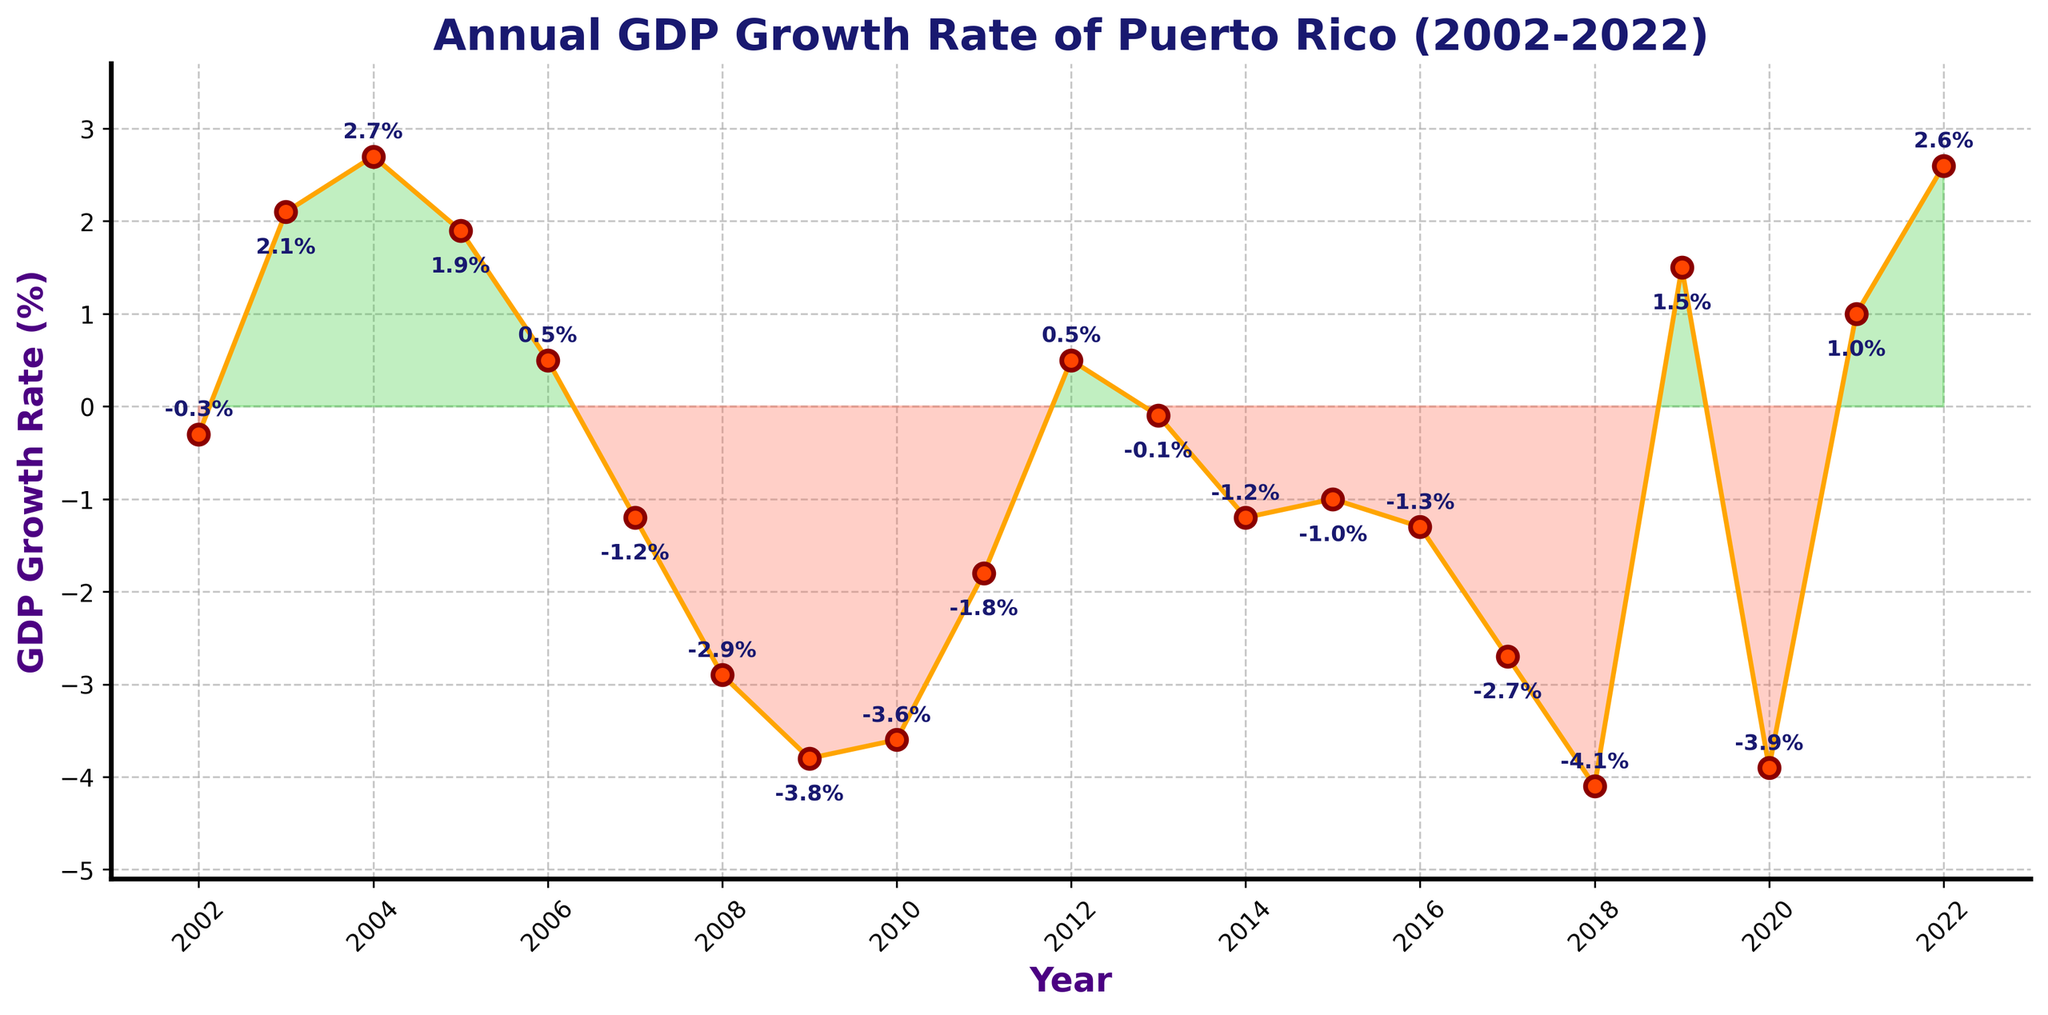Which year had the highest GDP growth rate? To find the year with the highest GDP growth rate, look for the peak point on the line plot. The highest point on the plot occurs in 2004.
Answer: 2004 How many years had a negative GDP growth rate? Count the number of points on the plot that are below the horizontal axis (0% growth rate). Eighteen points between 2002 and 2022 are below this line.
Answer: 12 Which year experienced the lowest GDP growth rate? The lowest point on the line chart represents the year with the lowest GDP growth rate. This lowest point is in 2018.
Answer: 2018 By how much did the GDP growth rate change between 2018 and 2019? Subtract the GDP growth rate in 2018 (-4.1%) from the GDP growth rate in 2019 (1.5%). The change is 1.5% - (-4.1%) = 5.6%.
Answer: 5.6% Compare the GDP growth rate in 2006 and 2022. Which is higher and by how much? To compare, subtract the GDP growth rate of 2006 (0.5%) from that of 2022 (2.6%). 2.6% is higher by 2.6% - 0.5% = 2.1%.
Answer: 2.6% is higher by 2.1% What is the average GDP growth rate between 2002 and 2010? To calculate the average, sum the GDP growth rates for each year between 2002 and 2010 and then divide by the number of years. The sum of the rates is -0.3 + 2.1 + 2.7 + 1.9 + 0.5 -1.2 -2.9 -3.8 -3.6 = -4.6. There are 9 years in total. Hence, the average is -4.6 / 9 ≈ -0.51.
Answer: -0.51% What is the overall trend in GDP growth rate from 2008 to 2015? Assessing from 2008 (-2.9%) to 2015 (-1.0%), the trend is generally negative with some fluctuations. The overall GDP growth rate is still declining over this period, but at a slower pace toward the end.
Answer: Generally declining Which two consecutive years had the greatest drop in GDP growth rate? To identify this, find the largest negative difference between GDP growth rates of consecutive years. The drop from 2017 (-2.7%) to 2018 (-4.1%) is the greatest, which is -4.1 - (-2.7) = -1.4.
Answer: 2017 to 2018 In which years did the GDP growth rate shift from positive to negative or vice versa? Find the points where the line crosses the horizontal axis. The GDP growth rate shifted in the years: 2007 (positive to negative), 2012 (negative to positive), and 2020 (positive to negative).
Answer: 2007, 2012, 2020 